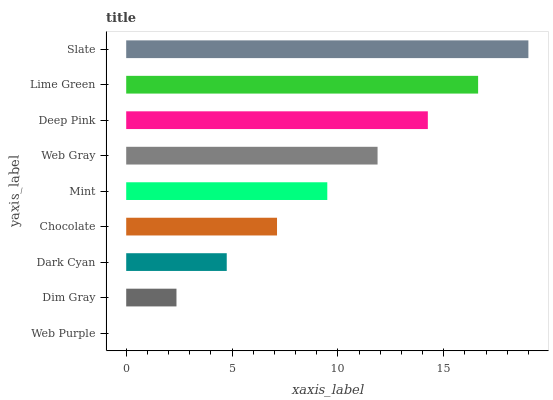Is Web Purple the minimum?
Answer yes or no. Yes. Is Slate the maximum?
Answer yes or no. Yes. Is Dim Gray the minimum?
Answer yes or no. No. Is Dim Gray the maximum?
Answer yes or no. No. Is Dim Gray greater than Web Purple?
Answer yes or no. Yes. Is Web Purple less than Dim Gray?
Answer yes or no. Yes. Is Web Purple greater than Dim Gray?
Answer yes or no. No. Is Dim Gray less than Web Purple?
Answer yes or no. No. Is Mint the high median?
Answer yes or no. Yes. Is Mint the low median?
Answer yes or no. Yes. Is Lime Green the high median?
Answer yes or no. No. Is Chocolate the low median?
Answer yes or no. No. 